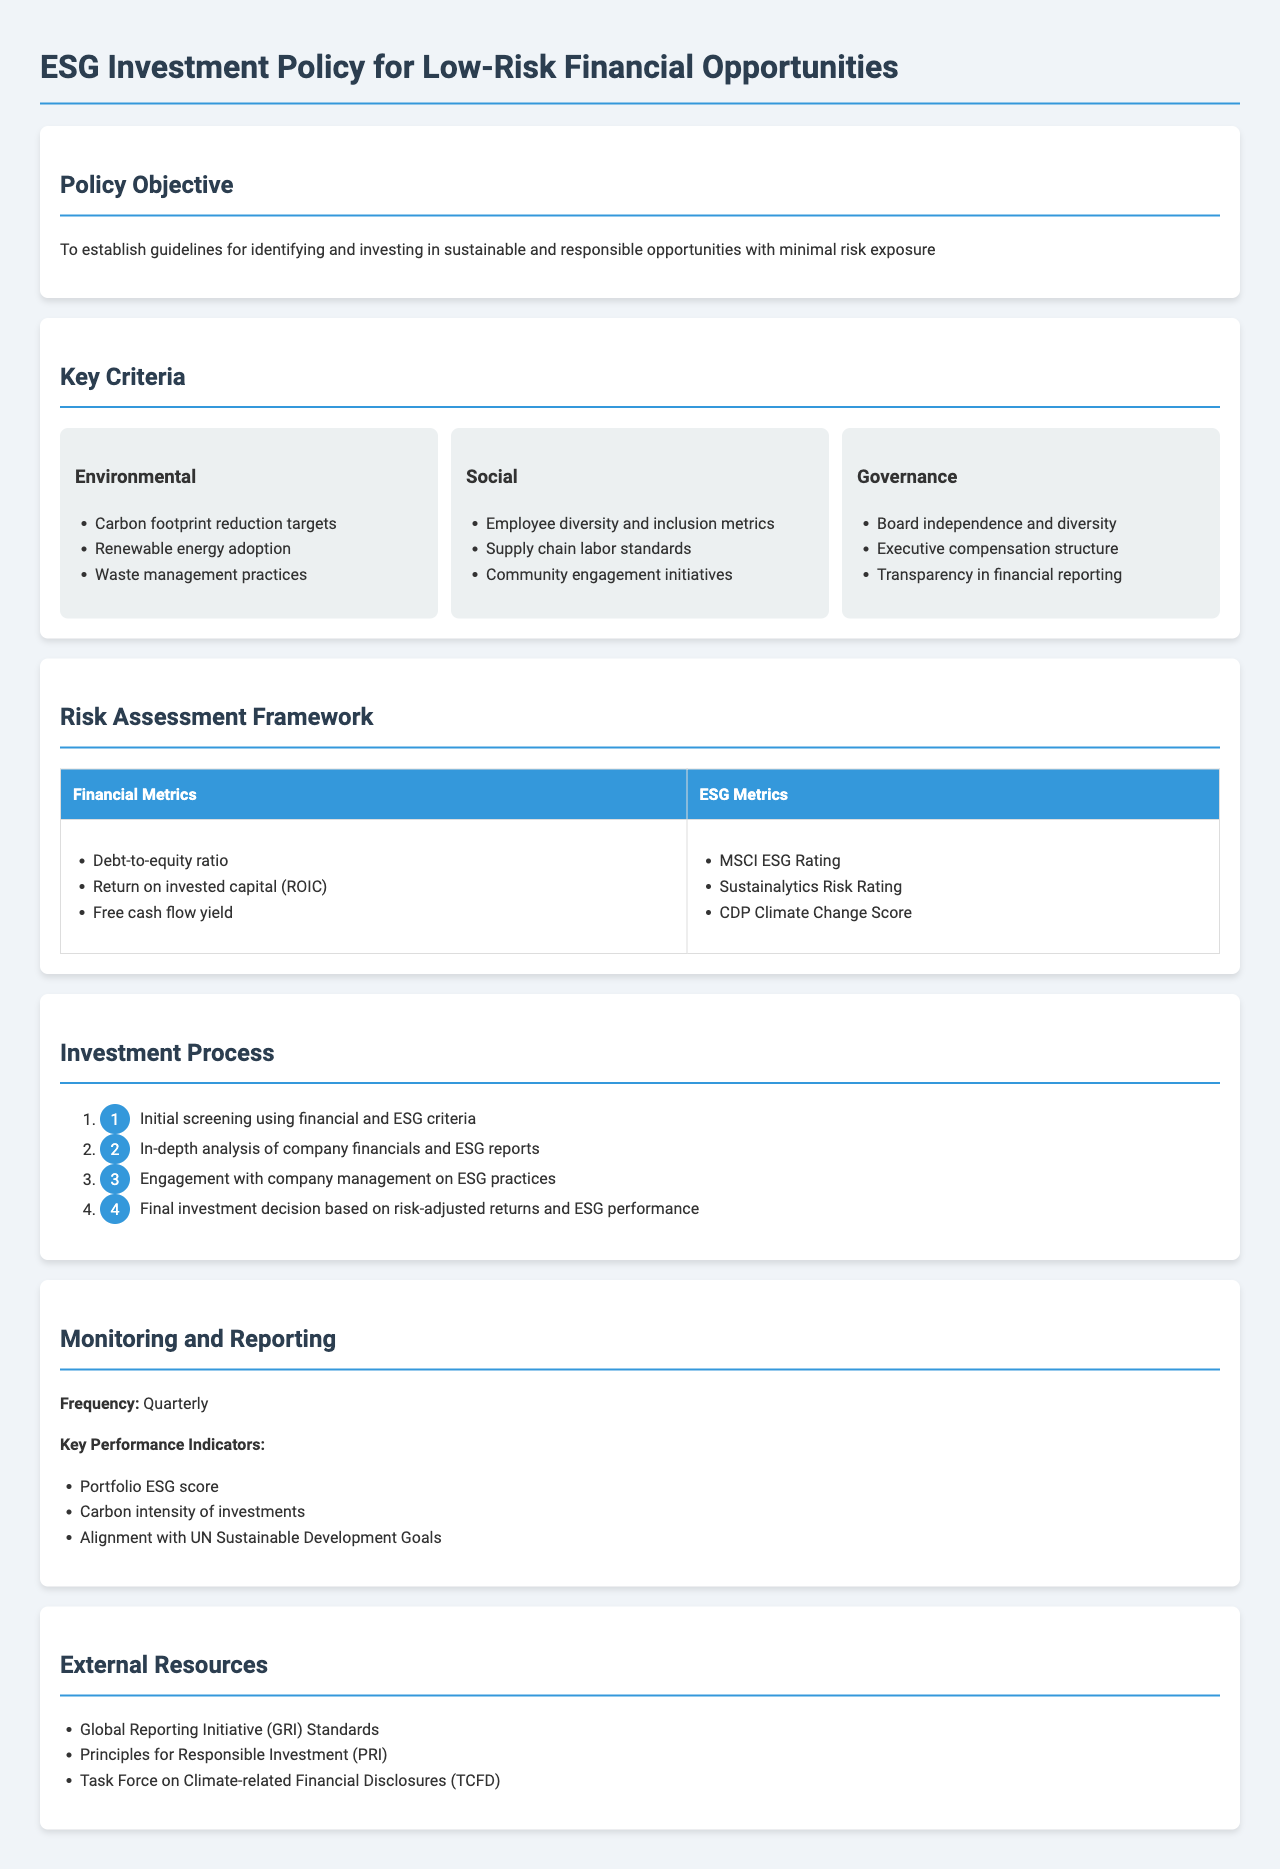What is the main objective of the ESG investment policy? The policy objective is to establish guidelines for identifying and investing in sustainable and responsible opportunities with minimal risk exposure.
Answer: minimal risk exposure What metric is included under Financial Metrics for risk assessment? The Financial Metrics include metrics such as Debt-to-equity ratio, which is listed in the document.
Answer: Debt-to-equity ratio Which organization’s standards are referenced for external resources? The document lists the Global Reporting Initiative (GRI) Standards as one of the external resources.
Answer: GRI How often is monitoring and reporting conducted? The document states that monitoring and reporting are conducted quarterly.
Answer: Quarterly What percentage of the investment assessment process involves engagement with company management? The document outlines that engagement with company management is part of the investment process but does not provide a specific percentage.
Answer: Not specified What is one of the key performance indicators mentioned in the monitoring section? The document lists Portfolio ESG score as one of the key performance indicators.
Answer: Portfolio ESG score What is the first step in the investment process? The first step is initial screening using financial and ESG criteria according to the document.
Answer: Initial screening Which ESG metric is specifically related to climate change? The CDP Climate Change Score is identified as an ESG metric related to climate change in the risk assessment framework.
Answer: CDP Climate Change Score What is one of the social criteria mentioned in the key criteria section? Employee diversity and inclusion metrics is one of the social criteria listed.
Answer: Employee diversity and inclusion metrics 